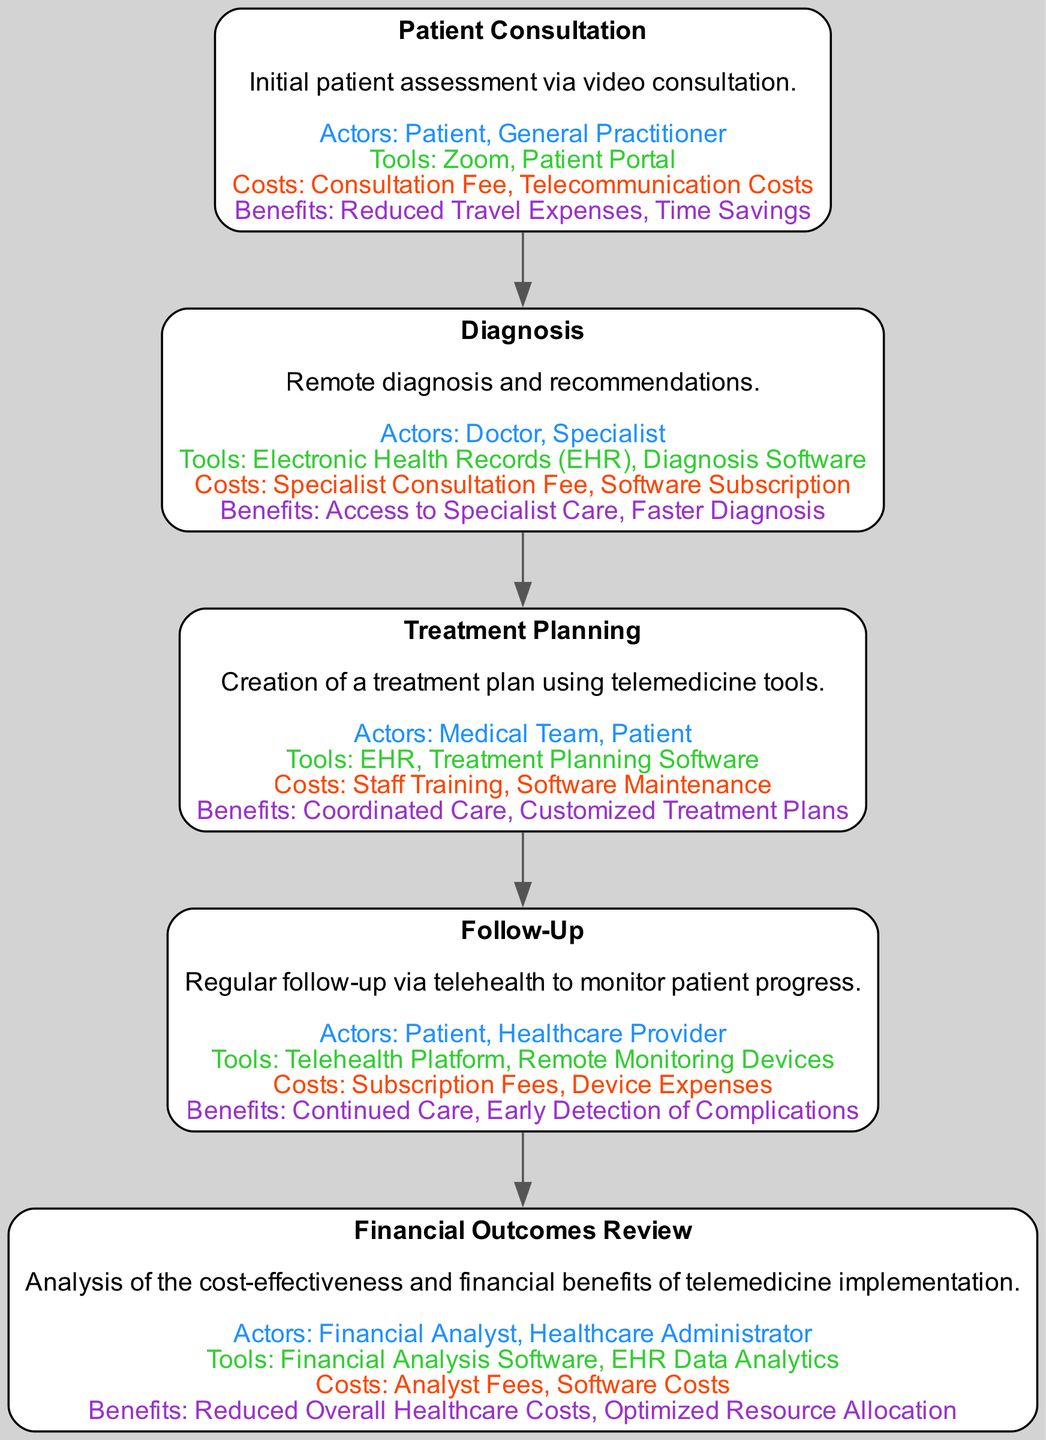What is the first stage in the pathway? The first stage in the diagram is "Patient Consultation". This can be determined by looking at the order of stages from top to bottom.
Answer: Patient Consultation Which tools are used in the Diagnosis stage? The tools listed for the Diagnosis stage include "Electronic Health Records (EHR)" and "Diagnosis Software". This information can be found in the description of the components for that stage.
Answer: Electronic Health Records (EHR), Diagnosis Software What are the benefits of the Follow-Up stage? The benefits highlighted for the Follow-Up stage are "Continued Care" and "Early Detection of Complications". By examining the benefits section in the Follow-Up components, we find this information.
Answer: Continued Care, Early Detection of Complications How many stages are there in total? There are five stages present in the diagram as each stage is clearly defined in the Elements section of the Clinical Pathway.
Answer: 5 What are the costs associated with the Financial Outcomes Review stage? The costs identified in the Financial Outcomes Review stage are "Analyst Fees" and "Software Costs". This is directly from the costs section of the components for that stage.
Answer: Analyst Fees, Software Costs Which role is involved in the Treatment Planning stage? The key actors involved in the Treatment Planning stage are "Medical Team" and "Patient". This can be found listed under the key actors for that specific stage.
Answer: Medical Team, Patient What is the relationship between Treatment Planning and Follow-Up stages? The Treatment Planning stage leads directly to the Follow-Up stage, indicating that the follow-up occurs after creating the treatment plan. This relationship can be traced by observing the flow in the diagram.
Answer: Leads to What is the primary benefit of implementing telemedicine according to the Financial Outcomes Review? The primary benefit listed in the Financial Outcomes Review is "Reduced Overall Healthcare Costs". By analyzing the benefits in that stage, we confirm this point.
Answer: Reduced Overall Healthcare Costs Which stage utilizes the telehealth platform? The Follow-Up stage utilizes the "Telehealth Platform". This is found in the tools section of the Follow-Up stage components.
Answer: Telehealth Platform 